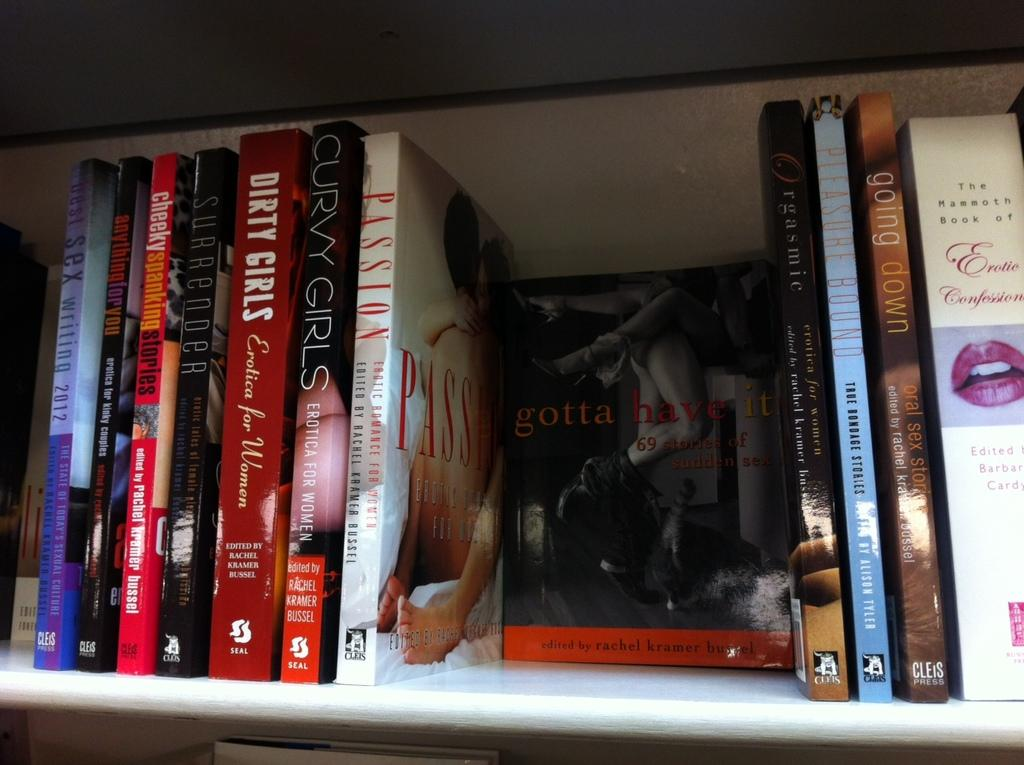<image>
Describe the image concisely. A book called Passion is on the shelf along with other books. 